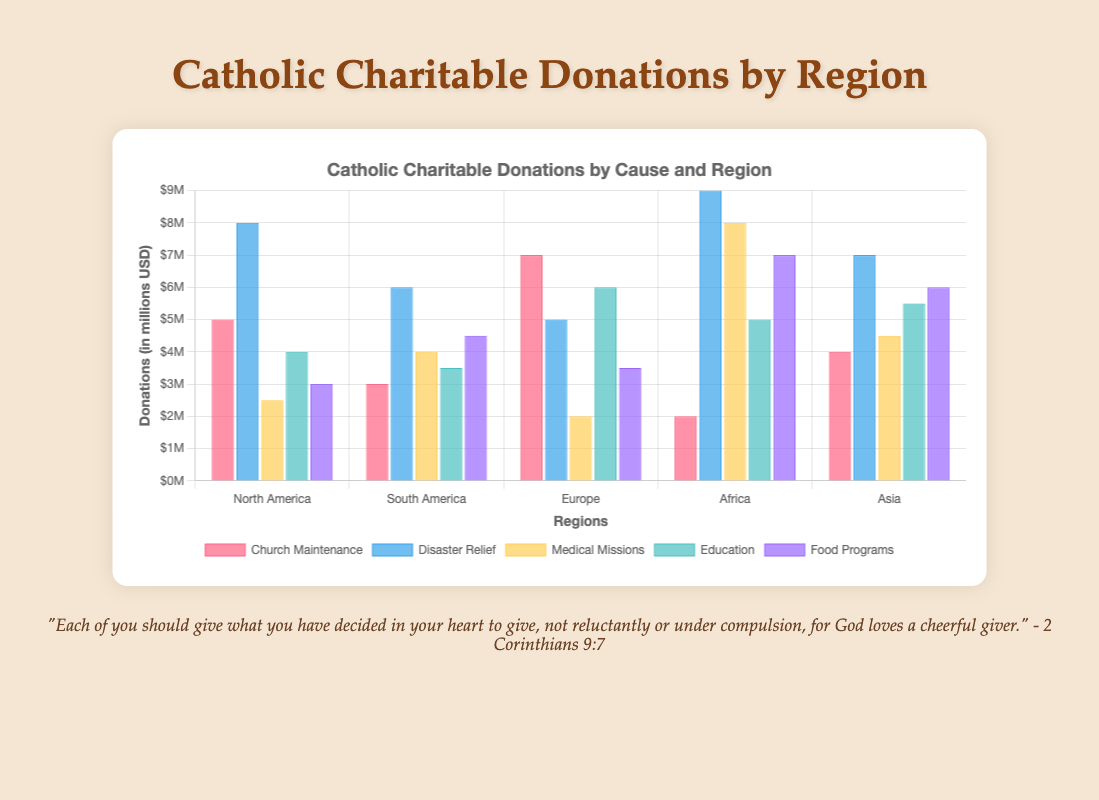Which region donates the most to Disaster Relief? To find the region that donates the most to Disaster Relief, look at the height of the bar representing Disaster Relief for each region. The tallest bar for Disaster Relief is in Africa.
Answer: Africa What is the total amount donated to Church Maintenance across all regions? Sum the amounts donated to Church Maintenance for each region: 5000000 (North America) + 3000000 (South America) + 7000000 (Europe) + 2000000 (Africa) + 4000000 (Asia) = 21000000
Answer: 21000000 Which cause has the least donations in Europe? Compare the heights of the bars corresponding to each cause in Europe. The shortest bar represents Medical Missions.
Answer: Medical Missions Which region has the highest total donation for Medical Missions? Compare the heights of the bars representing Medical Missions for each region. The tallest bar for Medical Missions is in Africa.
Answer: Africa What is the average donation amount for Education across all regions? Sum the donations for Education and divide by the number of regions: (4000000 + 3500000 + 6000000 + 5000000 + 5500000) / 5 = 24000000 / 5 = 4800000
Answer: 4800000 How much more does South America donate to Food Programs compared to North America? Subtract North America's Food Programs donation from South America's: 4500000 - 3000000 = 1500000
Answer: 1500000 What is the total amount donated to all causes in Asia? Sum the total donations for each cause in Asia: 4000000 (Church Maintenance) + 7000000 (Disaster Relief) + 4500000 (Medical Missions) + 5500000 (Education) + 6000000 (Food Programs) = 27000000
Answer: 27000000 Which cause receives the highest donation in North America? Compare the heights of the bars for each cause in North America. The tallest bar represents Disaster Relief.
Answer: Disaster Relief By how much does the donations for Food Programs in Africa exceed those for Medical Missions in Asia? Subtract Asia's Medical Missions donation from Africa's Food Programs donation: 7000000 - 4500000 = 2500000
Answer: 2500000 What is the difference between the highest and lowest amount donated to any cause in Europe? Find the highest and lowest donation amounts in Europe: 7000000 (Church Maintenance) - 2000000 (Medical Missions) = 5000000
Answer: 5000000 